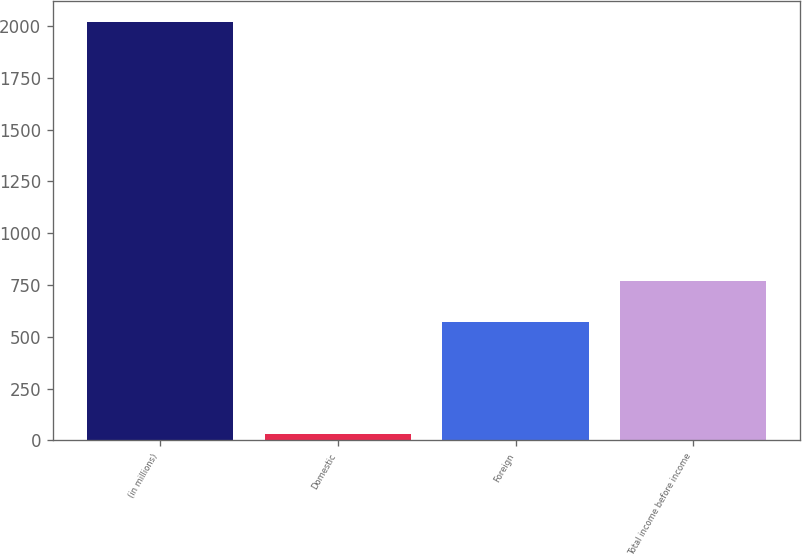Convert chart to OTSL. <chart><loc_0><loc_0><loc_500><loc_500><bar_chart><fcel>(in millions)<fcel>Domestic<fcel>Foreign<fcel>Total income before income<nl><fcel>2019<fcel>31.7<fcel>572.4<fcel>771.13<nl></chart> 